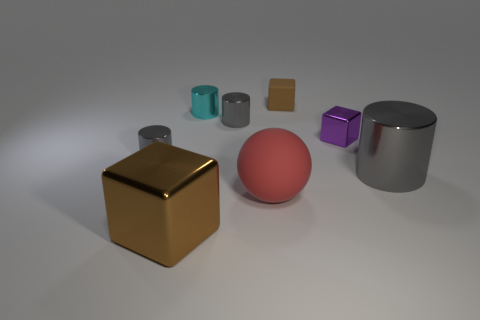Subtract all big metallic cylinders. How many cylinders are left? 3 Add 2 large red matte things. How many objects exist? 10 Subtract 1 blocks. How many blocks are left? 2 Subtract all brown cubes. How many cubes are left? 1 Subtract all spheres. How many objects are left? 7 Add 8 large red objects. How many large red objects are left? 9 Add 1 yellow things. How many yellow things exist? 1 Subtract 0 purple balls. How many objects are left? 8 Subtract all gray blocks. Subtract all blue spheres. How many blocks are left? 3 Subtract all green cubes. How many gray balls are left? 0 